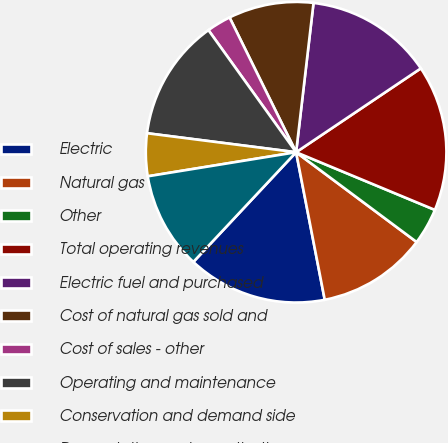<chart> <loc_0><loc_0><loc_500><loc_500><pie_chart><fcel>Electric<fcel>Natural gas<fcel>Other<fcel>Total operating revenues<fcel>Electric fuel and purchased<fcel>Cost of natural gas sold and<fcel>Cost of sales - other<fcel>Operating and maintenance<fcel>Conservation and demand side<fcel>Depreciation and amortization<nl><fcel>15.03%<fcel>11.76%<fcel>3.92%<fcel>15.69%<fcel>13.73%<fcel>9.15%<fcel>2.61%<fcel>13.07%<fcel>4.58%<fcel>10.46%<nl></chart> 